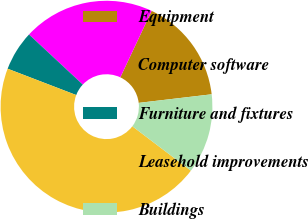<chart> <loc_0><loc_0><loc_500><loc_500><pie_chart><fcel>Equipment<fcel>Computer software<fcel>Furniture and fixtures<fcel>Leasehold improvements<fcel>Buildings<nl><fcel>16.13%<fcel>20.07%<fcel>6.1%<fcel>45.51%<fcel>12.19%<nl></chart> 